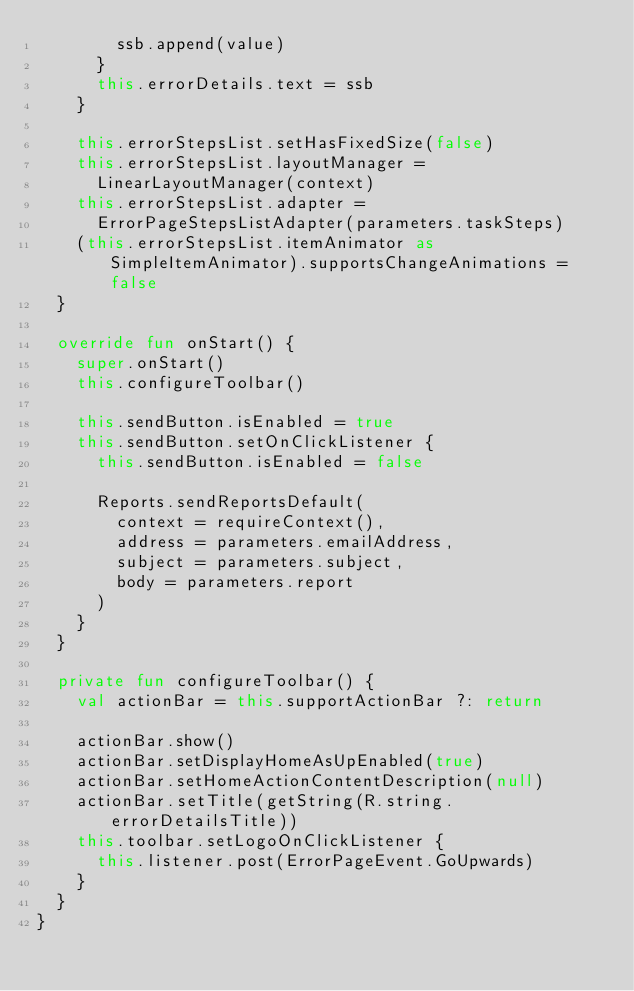<code> <loc_0><loc_0><loc_500><loc_500><_Kotlin_>        ssb.append(value)
      }
      this.errorDetails.text = ssb
    }

    this.errorStepsList.setHasFixedSize(false)
    this.errorStepsList.layoutManager =
      LinearLayoutManager(context)
    this.errorStepsList.adapter =
      ErrorPageStepsListAdapter(parameters.taskSteps)
    (this.errorStepsList.itemAnimator as SimpleItemAnimator).supportsChangeAnimations = false
  }

  override fun onStart() {
    super.onStart()
    this.configureToolbar()

    this.sendButton.isEnabled = true
    this.sendButton.setOnClickListener {
      this.sendButton.isEnabled = false

      Reports.sendReportsDefault(
        context = requireContext(),
        address = parameters.emailAddress,
        subject = parameters.subject,
        body = parameters.report
      )
    }
  }

  private fun configureToolbar() {
    val actionBar = this.supportActionBar ?: return

    actionBar.show()
    actionBar.setDisplayHomeAsUpEnabled(true)
    actionBar.setHomeActionContentDescription(null)
    actionBar.setTitle(getString(R.string.errorDetailsTitle))
    this.toolbar.setLogoOnClickListener {
      this.listener.post(ErrorPageEvent.GoUpwards)
    }
  }
}
</code> 